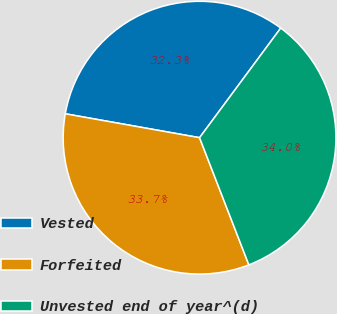Convert chart to OTSL. <chart><loc_0><loc_0><loc_500><loc_500><pie_chart><fcel>Vested<fcel>Forfeited<fcel>Unvested end of year^(d)<nl><fcel>32.34%<fcel>33.69%<fcel>33.97%<nl></chart> 